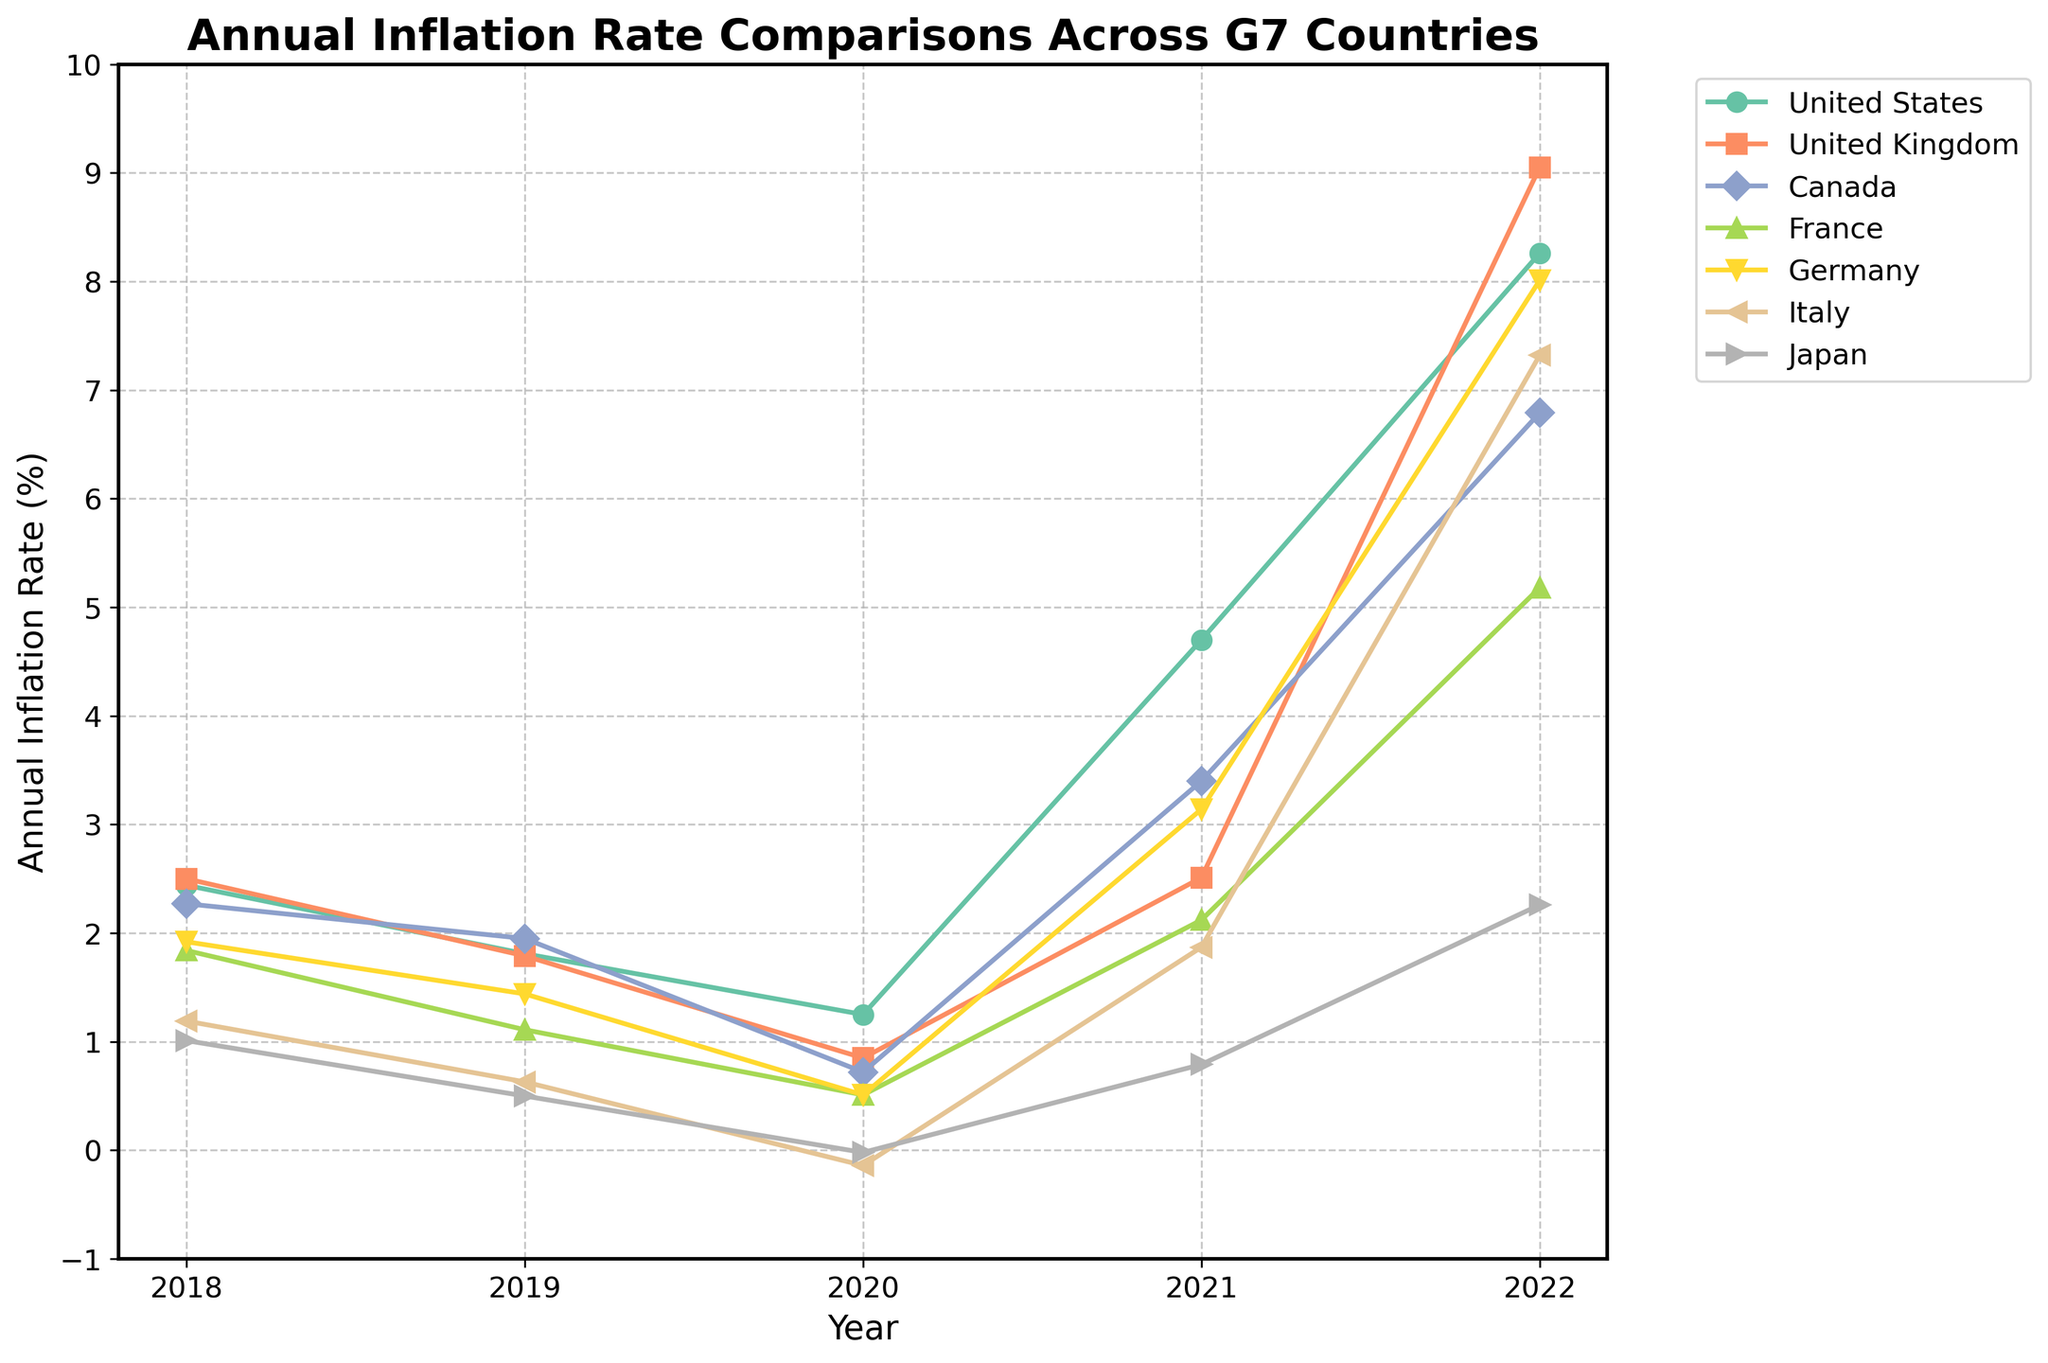What is the title of the plot? The title of the plot is written at the top and is "Annual Inflation Rate Comparisons Across G7 Countries".
Answer: Annual Inflation Rate Comparisons Across G7 Countries Which country had the highest annual inflation rate in 2022? By observing the end points of the plotted lines, the United Kingdom shows the highest annual inflation rate in 2022.
Answer: United Kingdom What was the trend in annual inflation rates for the United States from 2018 to 2022? The United States' annual inflation rate generally increased over this period, starting around 2.44% in 2018, dropping until 2020, then rising significantly through 2022 to reach around 8.26%.
Answer: Generally increasing How did the annual inflation rate in Japan change from 2020 to 2021? From seeing the points for Japan, the annual inflation rate increased from slightly below 0% in 2020 to just below 1% in 2021.
Answer: It increased What was the difference in annual inflation rate between Germany and Italy in 2019? Observing the plotted points, Germany's rate in 2019 was around 1.44%, and Italy’s rate was about 0.63%. The difference is approximately 1.44 - 0.63 = 0.81%.
Answer: 0.81% Did any country experience negative inflation rates, and if so, when? We see from the plot that both Italy and Japan had negative inflation rates around 2020.
Answer: Yes, in 2020 Which country had the most stable (least variable) annual inflation rates from 2018 to 2022? By comparing the fluctuations of the plotted lines, Japan's line is the most stable and shows the least variability over this period.
Answer: Japan In which year did most of the countries show a significant increase in their annual inflation rates? Looking at the increases in the plotted lines, most countries show a significant increase between 2021 and 2022.
Answer: Between 2021 and 2022 